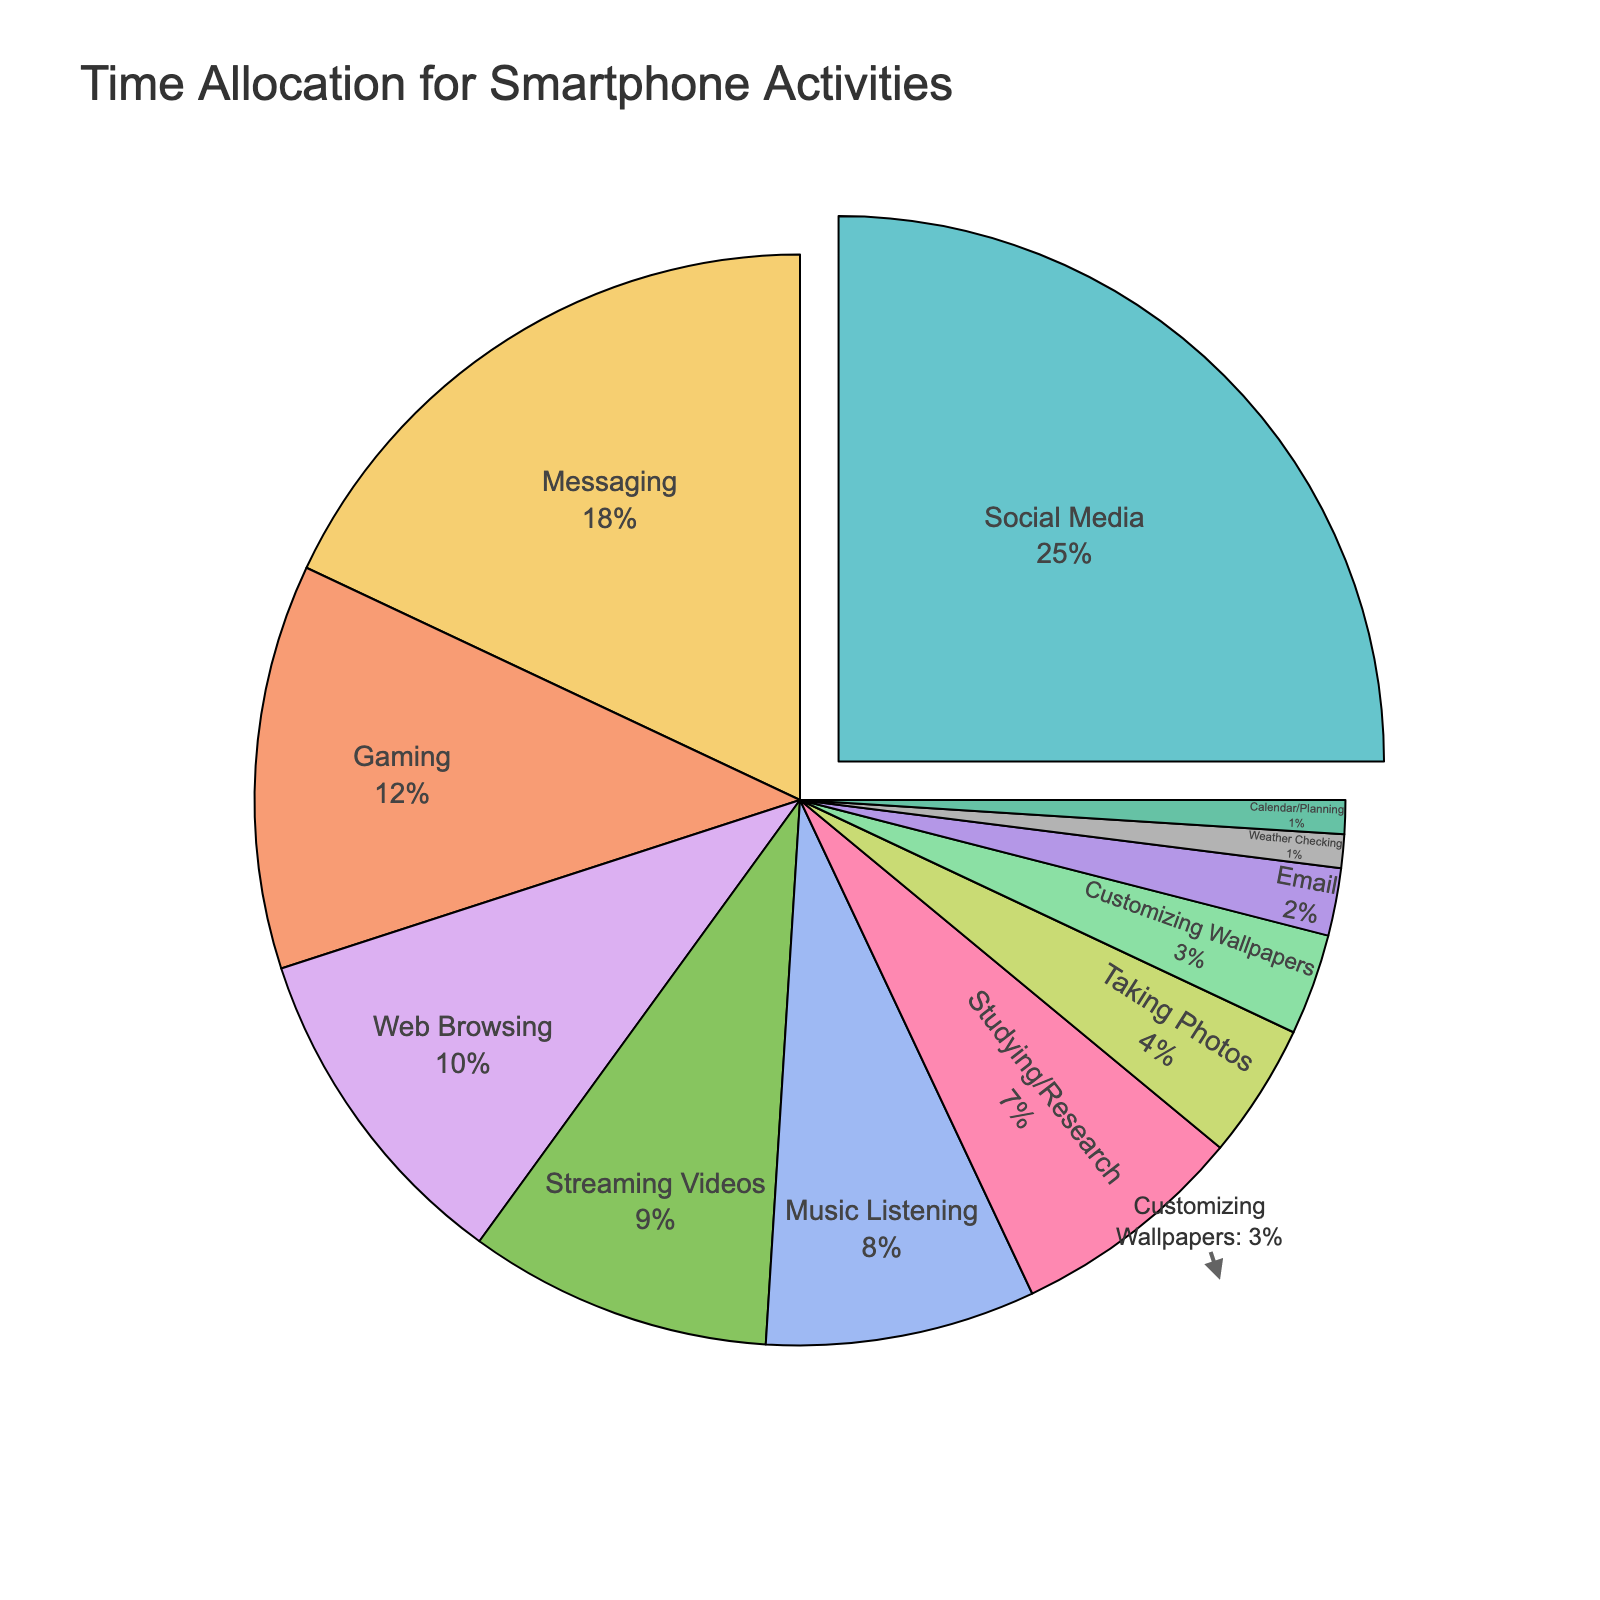Which activity takes the most time for college students? The pie chart clearly emphasizes one segment that indicates the largest percentage. By inspecting the chart, Social Media's segment is pulled out and labeled with the highest percentage of 25%.
Answer: Social Media How much more time is spent on Messaging than on Customizing Wallpapers? On examining the chart, Messaging takes up 18% and Customizing Wallpapers takes up 3%. The difference is calculated as 18% - 3%.
Answer: 15% What is the combined percentage of time spent on Gaming and Streaming Videos? From the chart, Gaming takes up 12% and Streaming Videos take up 9%. Summing up these percentages results in 12% + 9%.
Answer: 21% Which activities take up less than 5% of the time? By looking at the smaller segments, we see that Taking Photos (4%), Customizing Wallpapers (3%), Email (2%), Weather Checking (1%), and Calendar/Planning (1%) all fall into this range.
Answer: Taking Photos, Customizing Wallpapers, Email, Weather Checking, Calendar/Planning Are more time spent on Web Browsing or Music Listening? Comparing the two segments, Web Browsing takes up 10% and Music Listening takes up 8%. Hence, Web Browsing takes more time.
Answer: Web Browsing Is the time spent studying/researching greater or less than that spent on Streaming Videos? By inspecting the chart, Studying/Research takes up 7% and Streaming Videos take up 9%. Therefore, Studying/Research takes up less time.
Answer: Less What is the smallest activity segment and its percentage? Checking the smallest fraction on the pie chart, the smallest segments are Weather Checking and Calendar/Planning, each at 1%.
Answer: Weather Checking, Calendar/Planning How much time is spent on activities related to communication (Social Media, Messaging, Email)? By summing up the segments for Social Media (25%), Messaging (18%), and Email (2%), we get 25% + 18% + 2%.
Answer: 45% What percentage of the time is allocated to Media Activities (Streaming Videos, Music Listening, Gaming)? Adding up Streaming Videos (9%), Music Listening (8%), and Gaming (12%) from the pie chart, we get 9% + 8% + 12%.
Answer: 29% How does the size of the Customizing Wallpapers segment compare to that of the Gaming segment visually? The Customizing Wallpapers section (3%) is significantly smaller than the Gaming segment (12%), evident by the size difference in the pie chart.
Answer: Smaller 